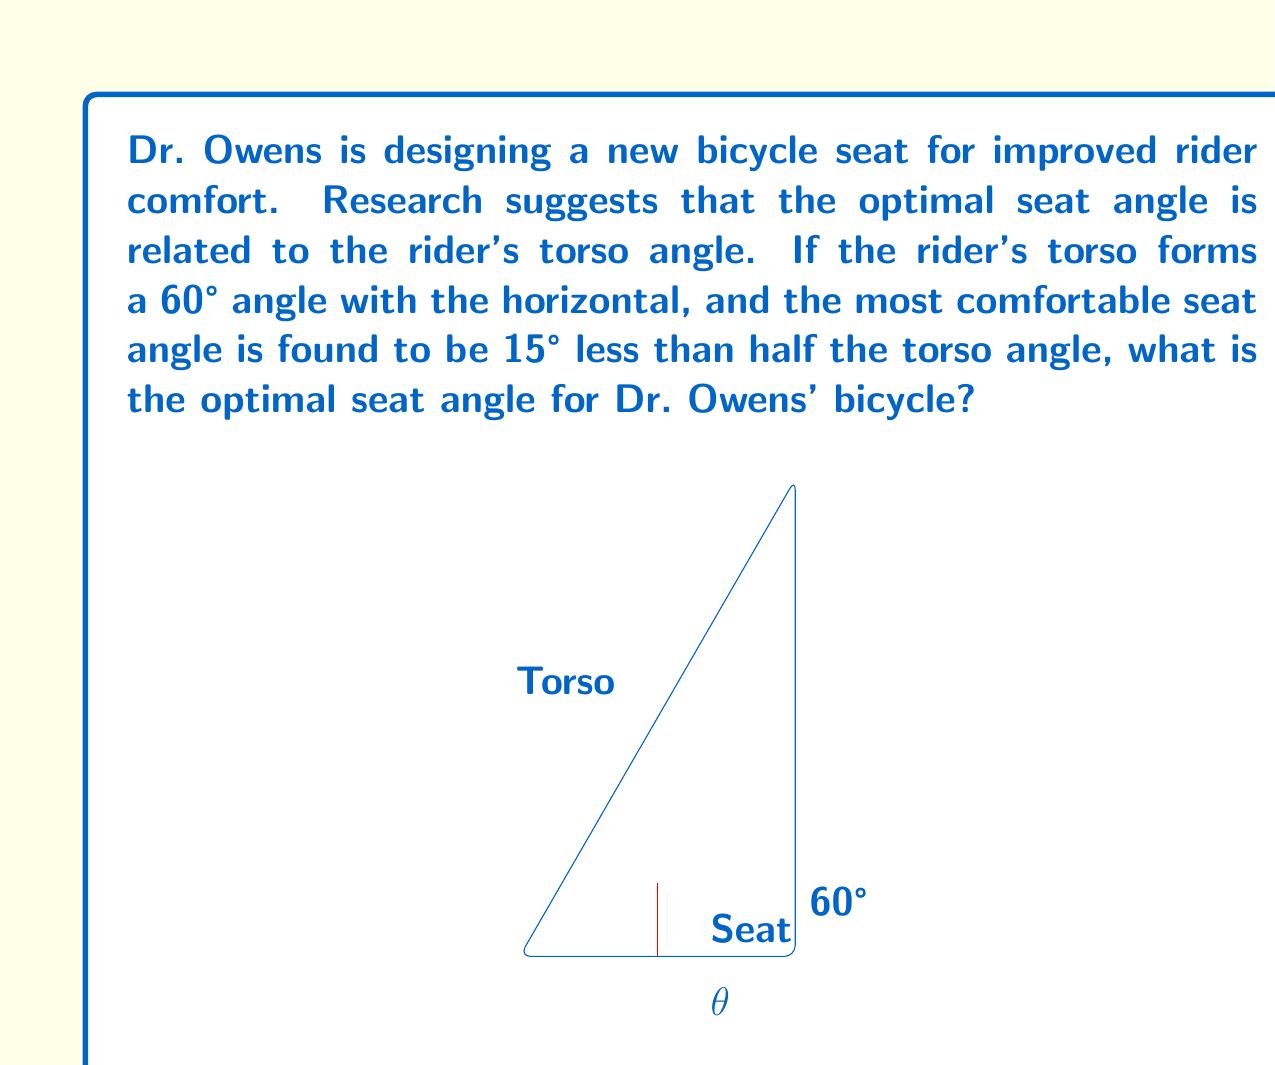Help me with this question. Let's approach this step-by-step:

1) First, we need to identify the given information:
   - The rider's torso forms a 60° angle with the horizontal.
   - The optimal seat angle is 15° less than half the torso angle.

2) Let's define the optimal seat angle as $\theta$.

3) We can express this mathematically as:
   $$\theta = \frac{1}{2} \cdot 60° - 15°$$

4) Now, let's solve this equation:
   $$\theta = 30° - 15°$$
   $$\theta = 15°$$

5) Therefore, the optimal seat angle for Dr. Owens' bicycle is 15°.

This angle should provide the best balance between comfort and efficiency for a rider with a 60° torso angle, based on the given relationship between torso and seat angles.
Answer: 15° 